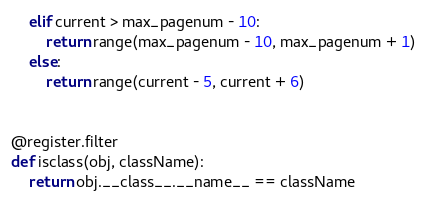<code> <loc_0><loc_0><loc_500><loc_500><_Python_>    elif current > max_pagenum - 10:
        return range(max_pagenum - 10, max_pagenum + 1)
    else:
        return range(current - 5, current + 6)


@register.filter
def isclass(obj, className):
    return obj.__class__.__name__ == className
</code> 